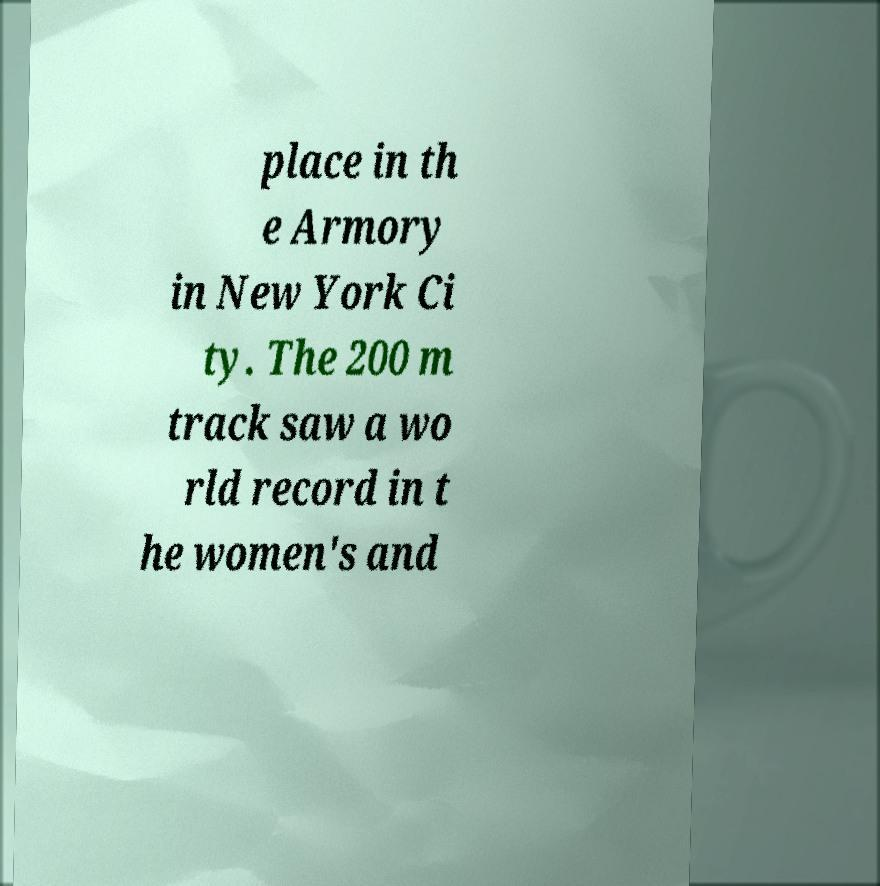Can you read and provide the text displayed in the image?This photo seems to have some interesting text. Can you extract and type it out for me? place in th e Armory in New York Ci ty. The 200 m track saw a wo rld record in t he women's and 